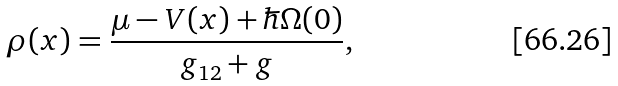<formula> <loc_0><loc_0><loc_500><loc_500>\rho ( x ) = \frac { \mu - V ( x ) + \hbar { \Omega } ( 0 ) } { g _ { 1 2 } + g } ,</formula> 